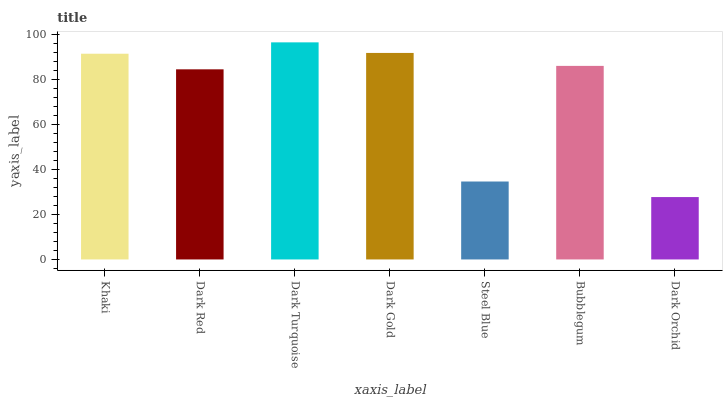Is Dark Orchid the minimum?
Answer yes or no. Yes. Is Dark Turquoise the maximum?
Answer yes or no. Yes. Is Dark Red the minimum?
Answer yes or no. No. Is Dark Red the maximum?
Answer yes or no. No. Is Khaki greater than Dark Red?
Answer yes or no. Yes. Is Dark Red less than Khaki?
Answer yes or no. Yes. Is Dark Red greater than Khaki?
Answer yes or no. No. Is Khaki less than Dark Red?
Answer yes or no. No. Is Bubblegum the high median?
Answer yes or no. Yes. Is Bubblegum the low median?
Answer yes or no. Yes. Is Khaki the high median?
Answer yes or no. No. Is Steel Blue the low median?
Answer yes or no. No. 